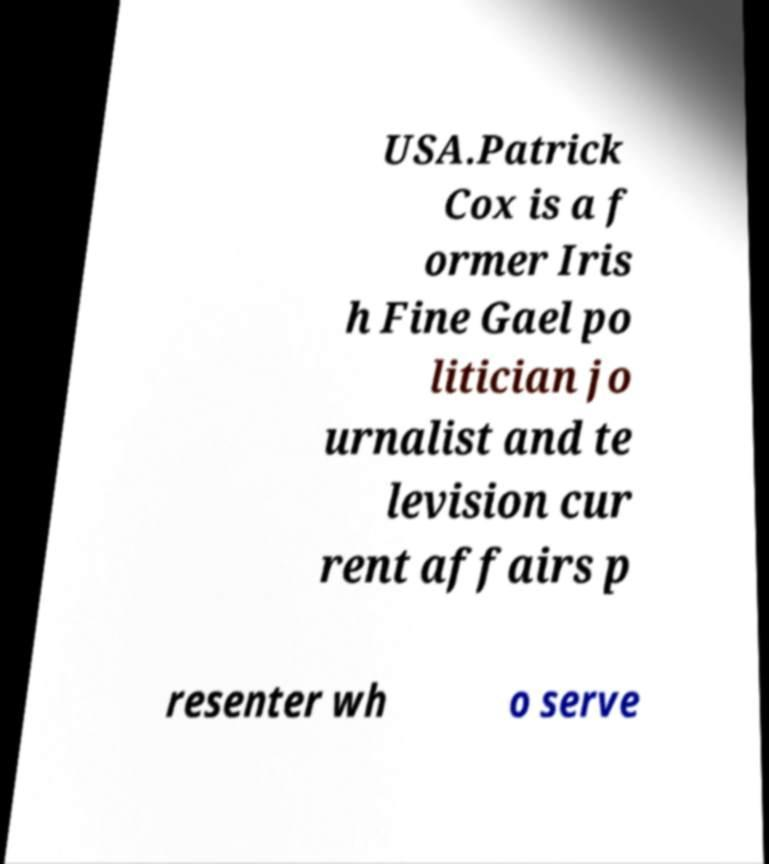Can you accurately transcribe the text from the provided image for me? USA.Patrick Cox is a f ormer Iris h Fine Gael po litician jo urnalist and te levision cur rent affairs p resenter wh o serve 